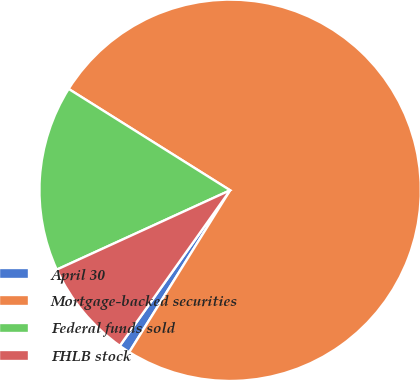<chart> <loc_0><loc_0><loc_500><loc_500><pie_chart><fcel>April 30<fcel>Mortgage-backed securities<fcel>Federal funds sold<fcel>FHLB stock<nl><fcel>0.95%<fcel>74.94%<fcel>15.75%<fcel>8.35%<nl></chart> 